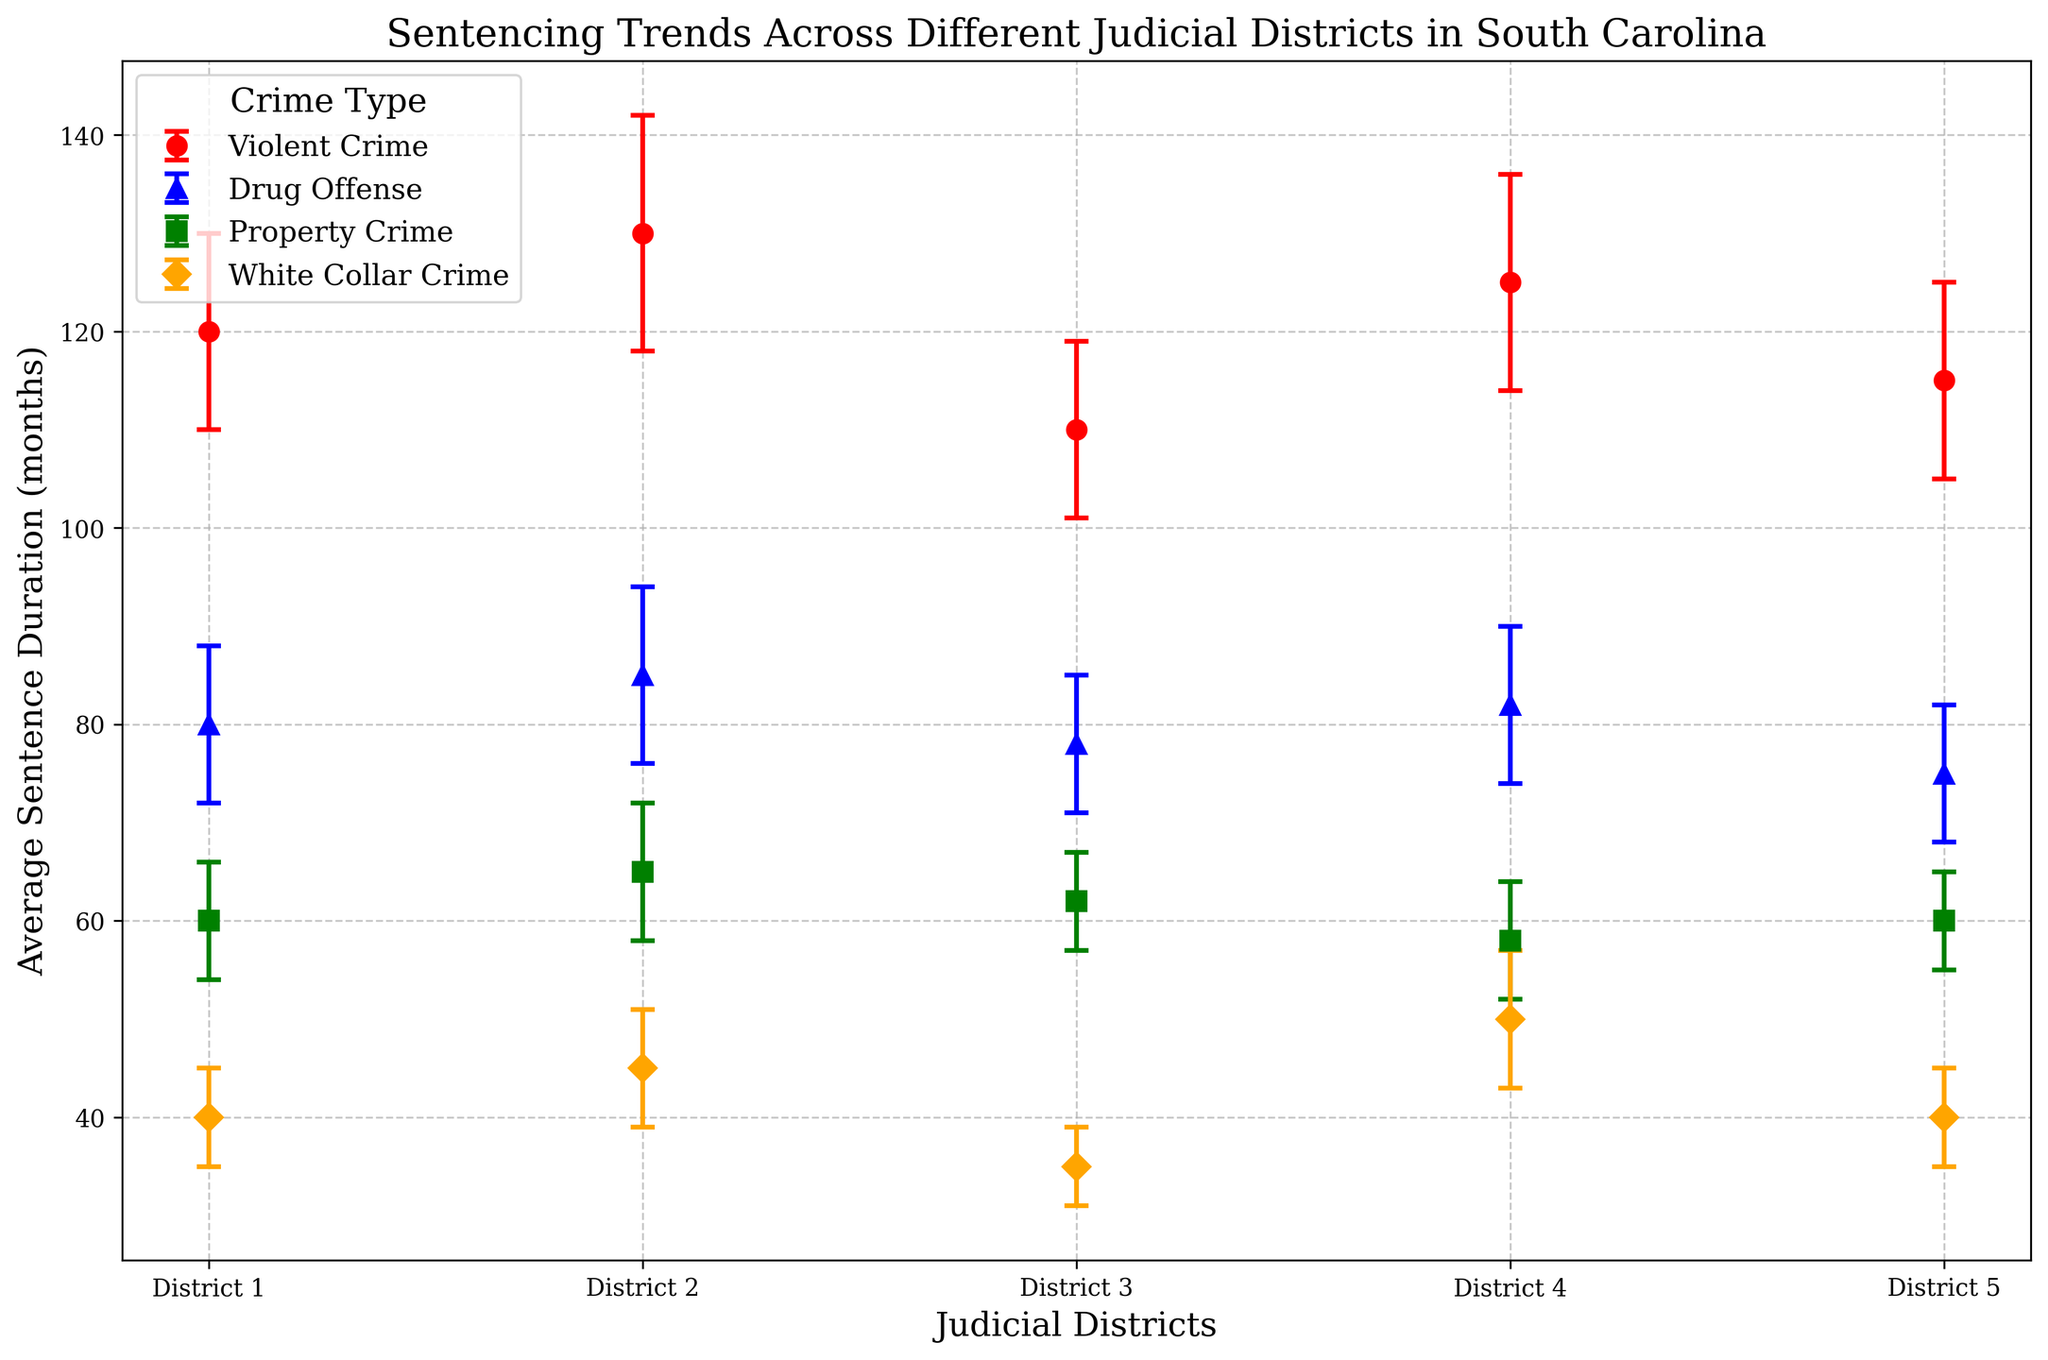What's the average sentence for violent crimes across all districts? To find the average sentence for violent crimes across all districts, add up the average sentences for violent crimes in each district and then divide by the number of districts. The values are 120, 130, 110, 125, and 115. Sum them: 120 + 130 + 110 + 125 + 115 = 600. Then, divide by 5 districts: 600/5 = 120.
Answer: 120 months Which district has the highest average sentence for white-collar crimes? To identify the district with the highest average sentence for white-collar crimes, compare the average sentences for white-collar crimes across all districts. The values are 40, 45, 35, 50, and 40. District 4 has the highest value of 50 months.
Answer: District 4 What is the difference in average sentence for drug offenses between District 2 and District 5? To find the difference, subtract the average sentence for drug offenses in District 5 from that in District 2. The values are 85 (District 2) and 75 (District 5). So, the difference is 85 - 75 = 10.
Answer: 10 months Which crime type in District 1 has the smallest error margin? By comparing the error margins for all crime types in District 1: Violent Crime (10), Drug Offense (8), Property Crime (6), and White Collar Crime (5), we see that White Collar Crime has the smallest error margin of 5 months.
Answer: White Collar Crime How many months more do violent crimes receive on average compared to drug offenses in District 3? To find the difference in average sentences between violent crimes and drug offenses in District 3, subtract the average sentence for drug offenses from that for violent crimes. The values are 110 (violent) and 78 (drug). So, 110 - 78 = 32.
Answer: 32 months Which crime type is consistently sentenced higher across all districts? Look at the average sentences for each crime type across all districts. Violent crimes have the highest sentences consistently across Districts 1, 2, 3, 4, and 5 (120, 130, 110, 125, and 115), which are higher than the sentences for other crime types in their respective districts.
Answer: Violent Crime Compare the average sentences for property crimes and drug offenses in District 4. Which one is higher? The average sentence for property crimes in District 4 is 58 months, while for drug offenses, it is 82 months. Since 82 is greater than 58, drug offenses have a higher average sentence.
Answer: Drug Offense What are the average error margins for property crimes across all districts? First, find the error margins for property crimes in each district: 6 (District 1), 7 (District 2), 5 (District 3), 6 (District 4), and 5 (District 5). Sum them up: 6 + 7 + 5 + 6 + 5 = 29. Then, divide by the 5 districts to get the average: 29/5 = 5.8.
Answer: 5.8 months 